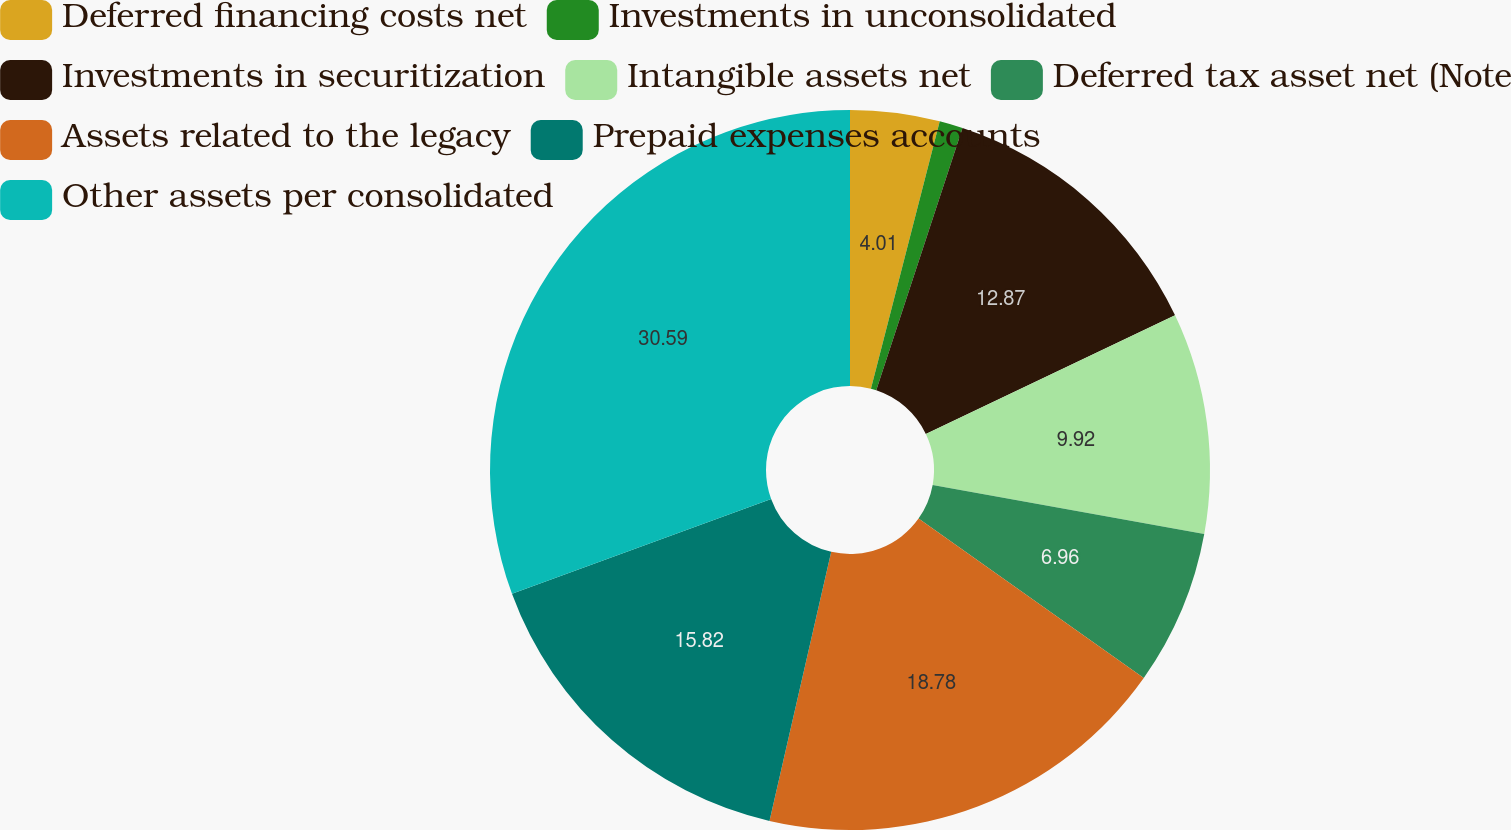Convert chart. <chart><loc_0><loc_0><loc_500><loc_500><pie_chart><fcel>Deferred financing costs net<fcel>Investments in unconsolidated<fcel>Investments in securitization<fcel>Intangible assets net<fcel>Deferred tax asset net (Note<fcel>Assets related to the legacy<fcel>Prepaid expenses accounts<fcel>Other assets per consolidated<nl><fcel>4.01%<fcel>1.05%<fcel>12.87%<fcel>9.92%<fcel>6.96%<fcel>18.78%<fcel>15.82%<fcel>30.59%<nl></chart> 